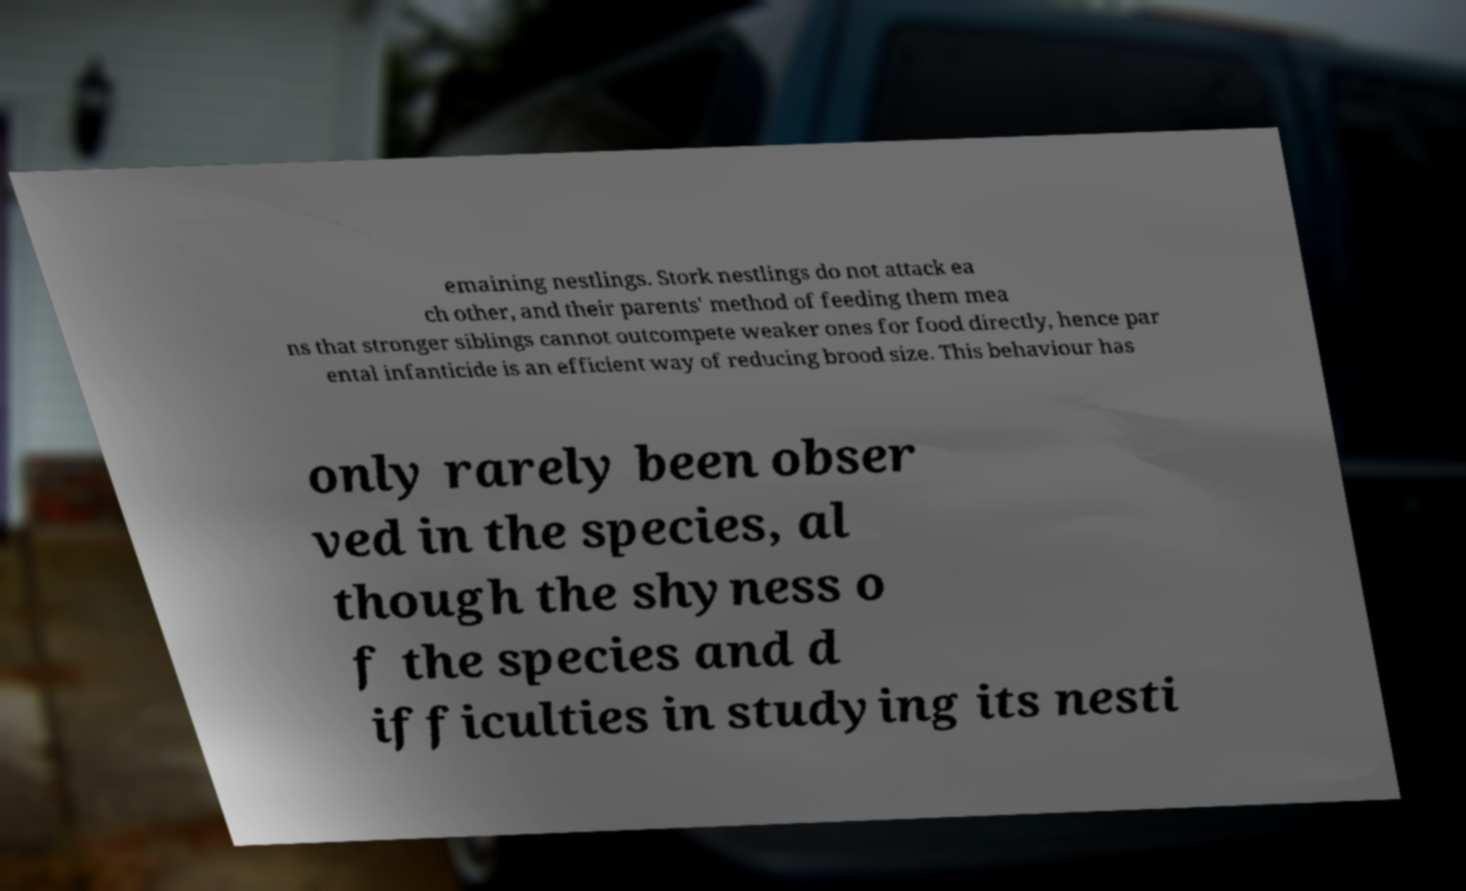Please identify and transcribe the text found in this image. emaining nestlings. Stork nestlings do not attack ea ch other, and their parents' method of feeding them mea ns that stronger siblings cannot outcompete weaker ones for food directly, hence par ental infanticide is an efficient way of reducing brood size. This behaviour has only rarely been obser ved in the species, al though the shyness o f the species and d ifficulties in studying its nesti 